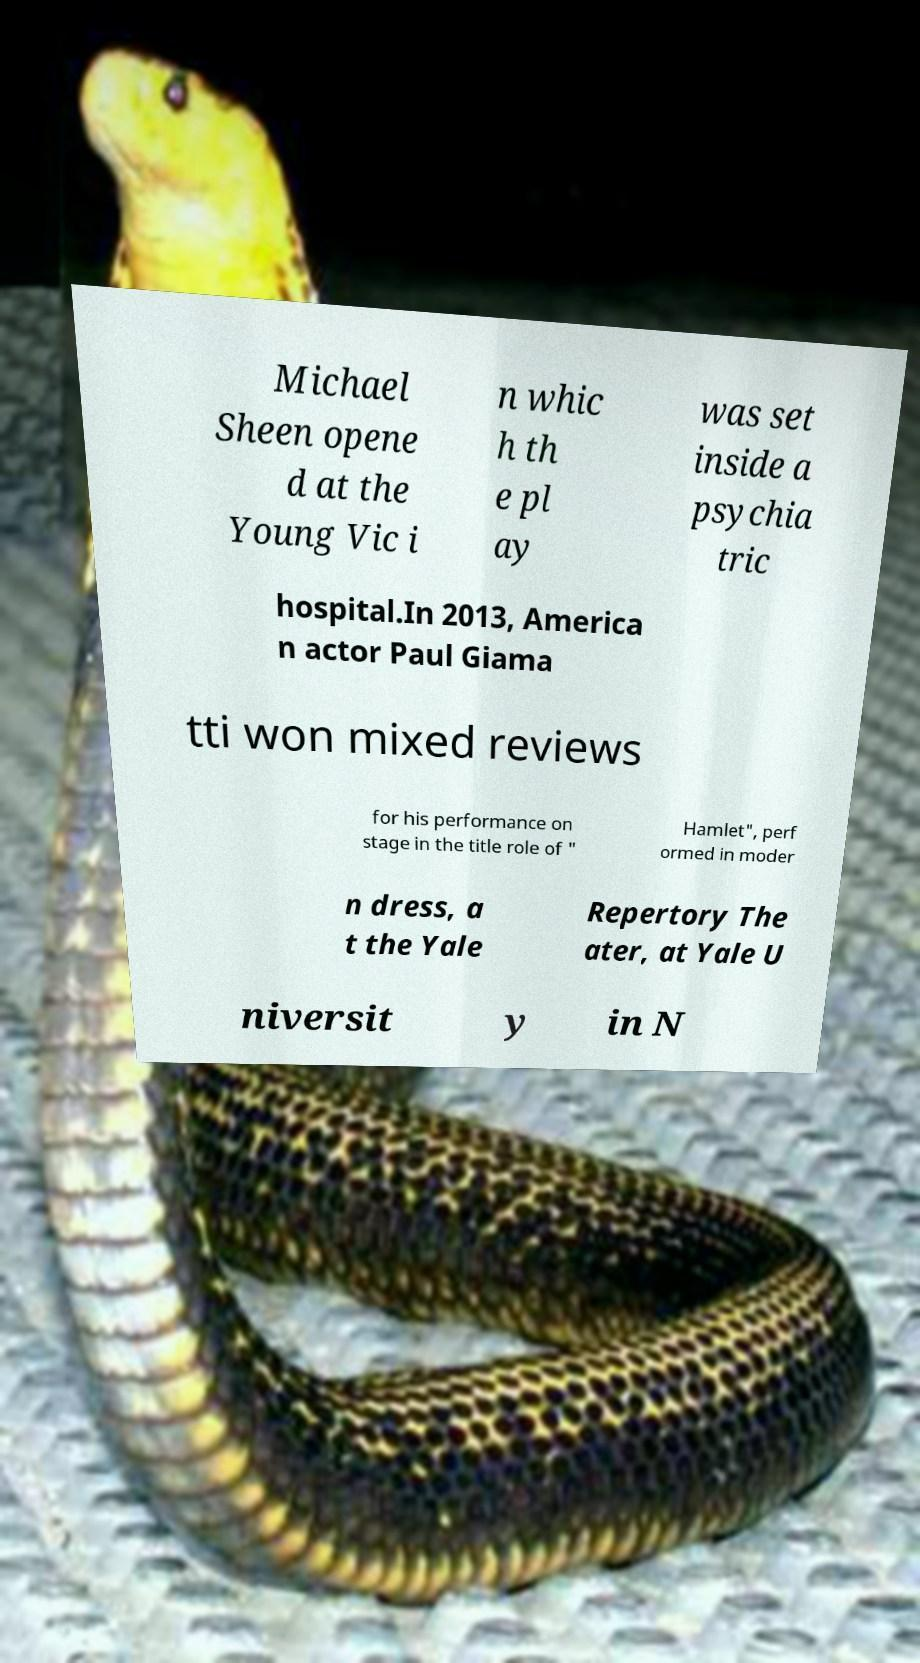What messages or text are displayed in this image? I need them in a readable, typed format. Michael Sheen opene d at the Young Vic i n whic h th e pl ay was set inside a psychia tric hospital.In 2013, America n actor Paul Giama tti won mixed reviews for his performance on stage in the title role of " Hamlet", perf ormed in moder n dress, a t the Yale Repertory The ater, at Yale U niversit y in N 